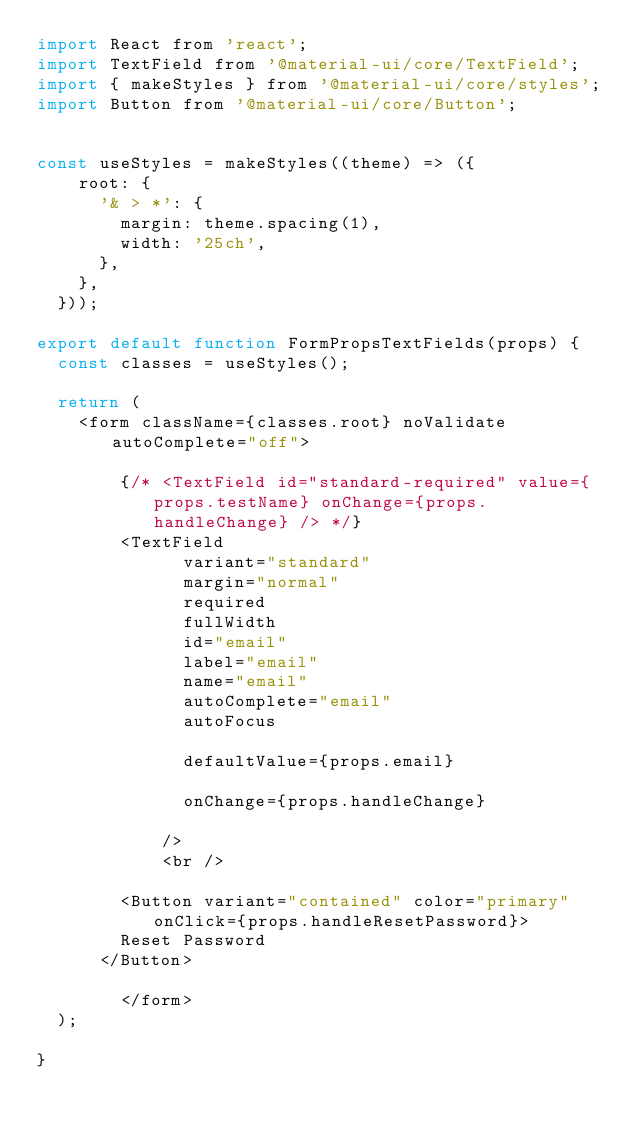Convert code to text. <code><loc_0><loc_0><loc_500><loc_500><_JavaScript_>import React from 'react';
import TextField from '@material-ui/core/TextField';
import { makeStyles } from '@material-ui/core/styles';
import Button from '@material-ui/core/Button';


const useStyles = makeStyles((theme) => ({
    root: {
      '& > *': {
        margin: theme.spacing(1),
        width: '25ch',
      },
    },
  }));

export default function FormPropsTextFields(props) {
  const classes = useStyles();

  return (
    <form className={classes.root} noValidate autoComplete="off">
      
        {/* <TextField id="standard-required" value={props.testName} onChange={props.handleChange} /> */}
        <TextField
              variant="standard"
              margin="normal"
              required
              fullWidth
              id="email"
              label="email"
              name="email"
              autoComplete="email"
              autoFocus

              defaultValue={props.email}

              onChange={props.handleChange}

            />
            <br />    
            
        <Button variant="contained" color="primary" onClick={props.handleResetPassword}>
        Reset Password
      </Button>

        </form>
  );

}</code> 